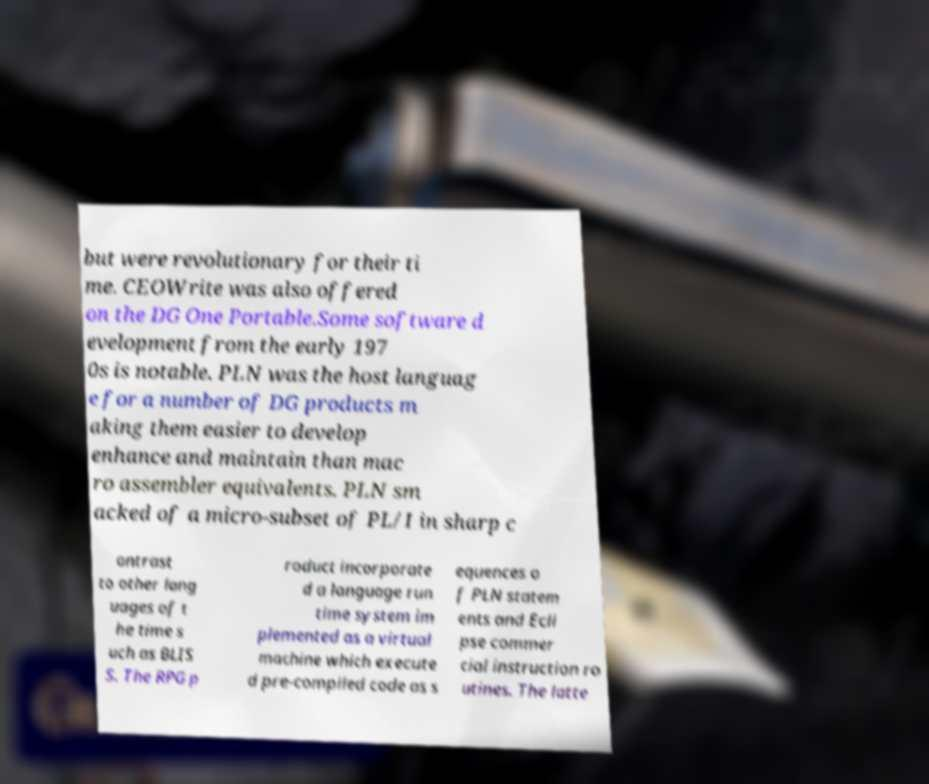What messages or text are displayed in this image? I need them in a readable, typed format. but were revolutionary for their ti me. CEOWrite was also offered on the DG One Portable.Some software d evelopment from the early 197 0s is notable. PLN was the host languag e for a number of DG products m aking them easier to develop enhance and maintain than mac ro assembler equivalents. PLN sm acked of a micro-subset of PL/I in sharp c ontrast to other lang uages of t he time s uch as BLIS S. The RPG p roduct incorporate d a language run time system im plemented as a virtual machine which execute d pre-compiled code as s equences o f PLN statem ents and Ecli pse commer cial instruction ro utines. The latte 